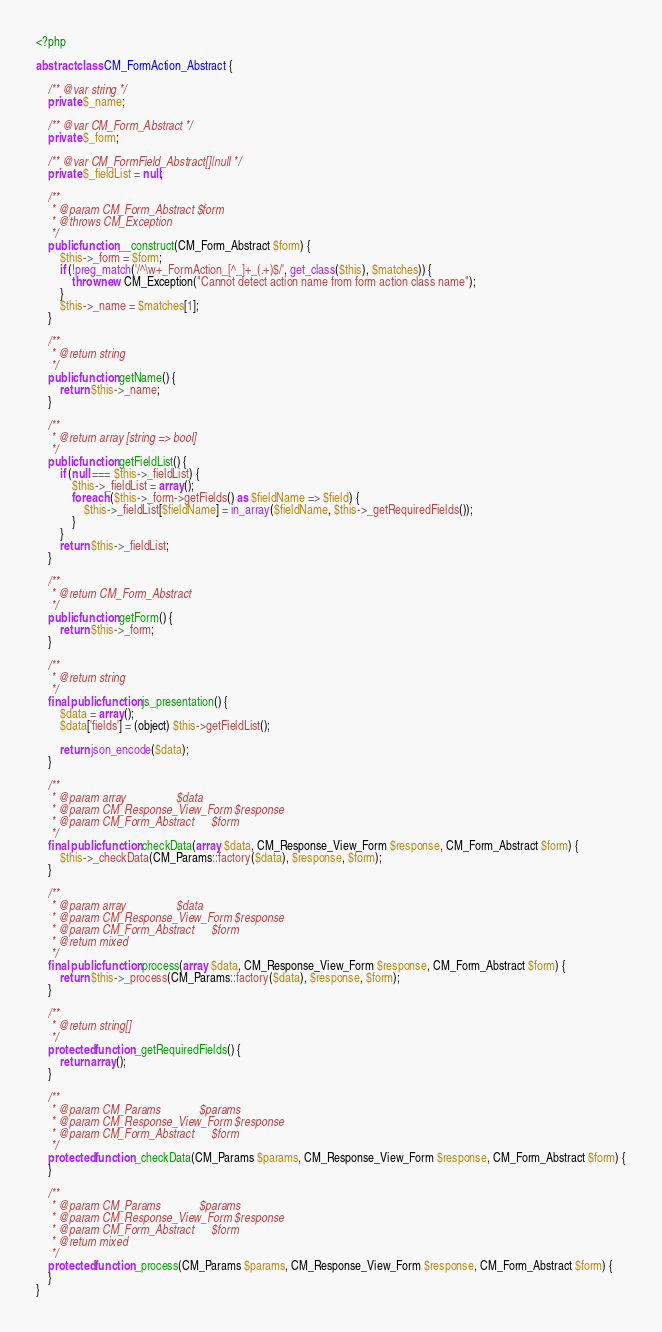Convert code to text. <code><loc_0><loc_0><loc_500><loc_500><_PHP_><?php

abstract class CM_FormAction_Abstract {

	/** @var string */
	private $_name;

	/** @var CM_Form_Abstract */
	private $_form;

	/** @var CM_FormField_Abstract[]|null */
	private $_fieldList = null;

	/**
	 * @param CM_Form_Abstract $form
	 * @throws CM_Exception
	 */
	public function __construct(CM_Form_Abstract $form) {
		$this->_form = $form;
		if (!preg_match('/^\w+_FormAction_[^_]+_(.+)$/', get_class($this), $matches)) {
			throw new CM_Exception("Cannot detect action name from form action class name");
		}
		$this->_name = $matches[1];
	}

	/**
	 * @return string
	 */
	public function getName() {
		return $this->_name;
	}

	/**
	 * @return array [string => bool]
	 */
	public function getFieldList() {
		if (null === $this->_fieldList) {
			$this->_fieldList = array();
			foreach ($this->_form->getFields() as $fieldName => $field) {
				$this->_fieldList[$fieldName] = in_array($fieldName, $this->_getRequiredFields());
			}
		}
		return $this->_fieldList;
	}

	/**
	 * @return CM_Form_Abstract
	 */
	public function getForm() {
		return $this->_form;
	}

	/**
	 * @return string
	 */
	final public function js_presentation() {
		$data = array();
		$data['fields'] = (object) $this->getFieldList();

		return json_encode($data);
	}

	/**
	 * @param array                 $data
	 * @param CM_Response_View_Form $response
	 * @param CM_Form_Abstract      $form
	 */
	final public function checkData(array $data, CM_Response_View_Form $response, CM_Form_Abstract $form) {
		$this->_checkData(CM_Params::factory($data), $response, $form);
	}

	/**
	 * @param array                 $data
	 * @param CM_Response_View_Form $response
	 * @param CM_Form_Abstract      $form
	 * @return mixed
	 */
	final public function process(array $data, CM_Response_View_Form $response, CM_Form_Abstract $form) {
		return $this->_process(CM_Params::factory($data), $response, $form);
	}

	/**
	 * @return string[]
	 */
	protected function _getRequiredFields() {
		return array();
	}

	/**
	 * @param CM_Params             $params
	 * @param CM_Response_View_Form $response
	 * @param CM_Form_Abstract      $form
	 */
	protected function _checkData(CM_Params $params, CM_Response_View_Form $response, CM_Form_Abstract $form) {
	}

	/**
	 * @param CM_Params             $params
	 * @param CM_Response_View_Form $response
	 * @param CM_Form_Abstract      $form
	 * @return mixed
	 */
	protected function _process(CM_Params $params, CM_Response_View_Form $response, CM_Form_Abstract $form) {
	}
}
</code> 